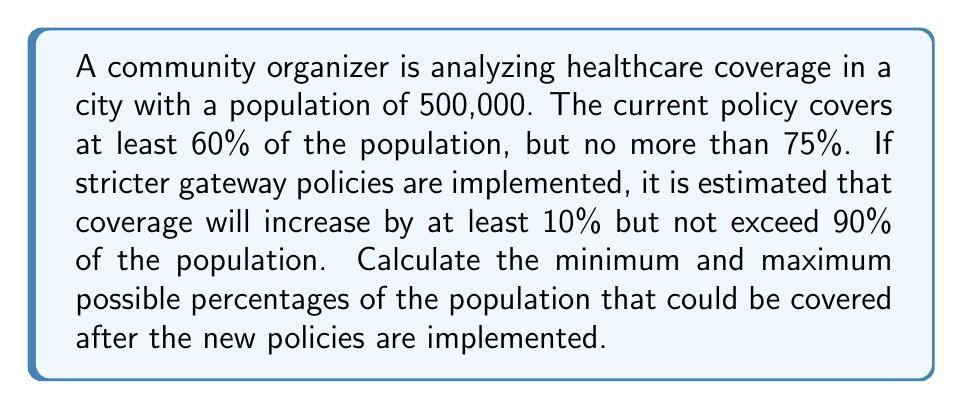What is the answer to this math problem? Let's approach this step-by-step:

1) First, let's define our variables:
   Let $x$ be the current percentage of the population covered
   Let $y$ be the percentage of the population covered after new policies

2) Given information about current coverage:
   $60\% \leq x \leq 75\%$

3) We're told that coverage will increase by at least 10%:
   $y \geq x + 10\%$

4) We're also told that coverage won't exceed 90%:
   $y \leq 90\%$

5) To find the minimum possible coverage after new policies:
   - Start with the minimum current coverage: $x = 60\%$
   - Add the minimum increase: $y = 60\% + 10\% = 70\%$

6) To find the maximum possible coverage after new policies:
   - We're limited by the 90% cap, so $y = 90\%$

7) Therefore, the range of possible coverage after new policies is:
   $70\% \leq y \leq 90\%$

8) Converting to percentages:
   Minimum: $70\% = 70\%$
   Maximum: $90\% = 90\%$
Answer: Minimum: 70%, Maximum: 90% 